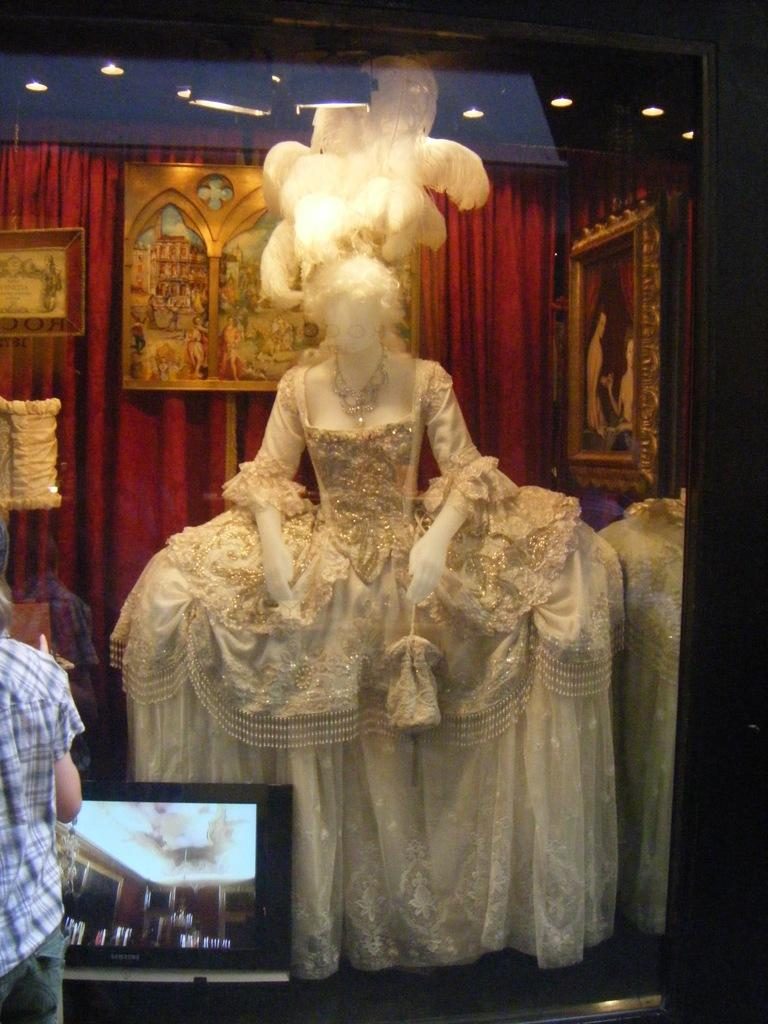What is the mannequin wearing in the image? The mannequin is wearing a white dress in the image. What is the color of the curtain with pictures on it? The curtain with pictures on it is red. Can you describe the person visible in the image? There is a person visible in the image, but no specific details about their appearance are provided. What is the purpose of the screen in the image? The purpose of the screen in the image is not specified, but it could be used for displaying images or videos. What type of bread is being used to make the person's costume in the image? There is no bread or costume present in the image; it features a mannequin wearing a white dress and a person visible in the background. 